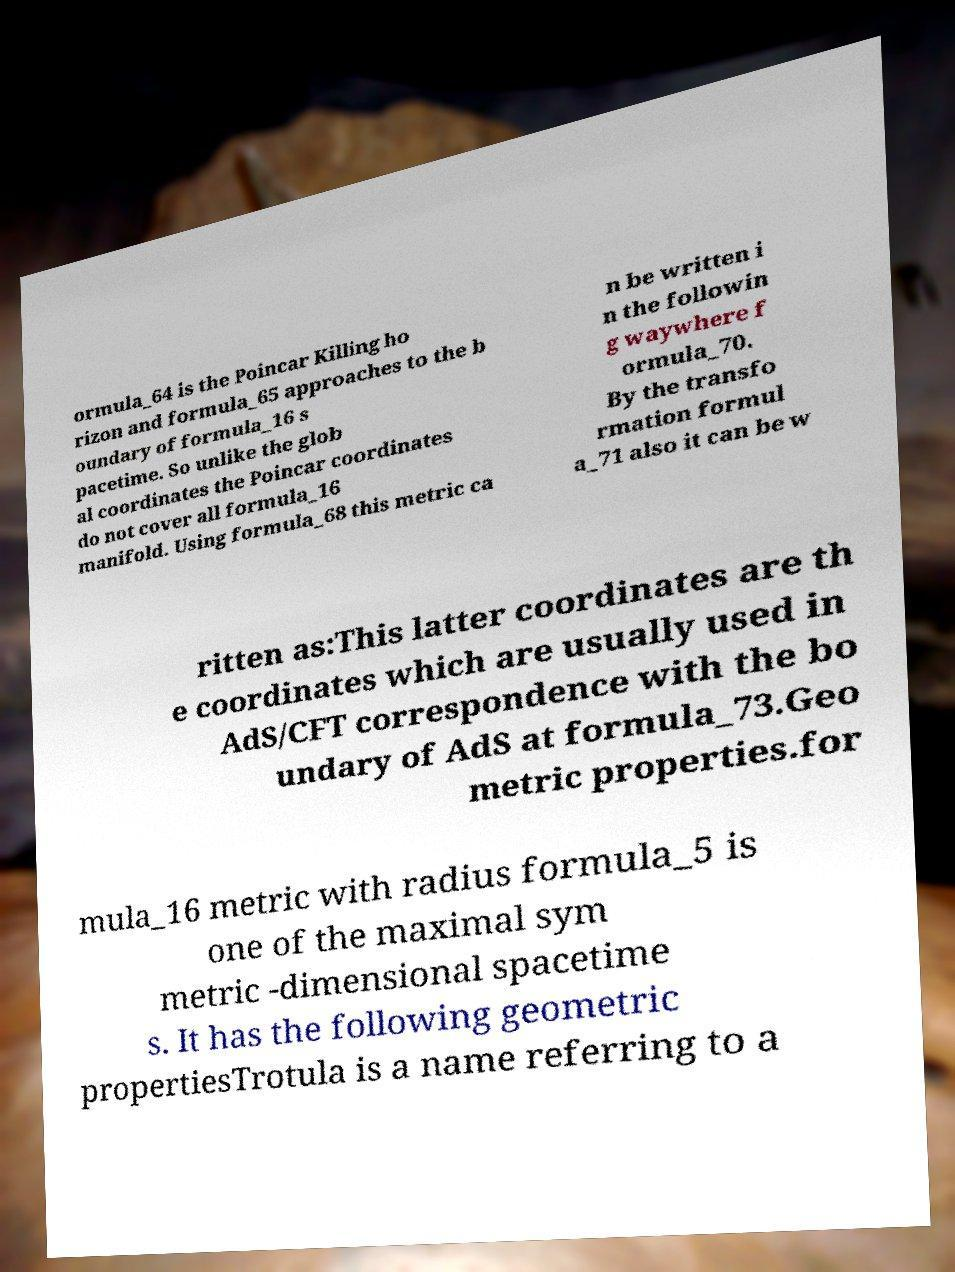For documentation purposes, I need the text within this image transcribed. Could you provide that? ormula_64 is the Poincar Killing ho rizon and formula_65 approaches to the b oundary of formula_16 s pacetime. So unlike the glob al coordinates the Poincar coordinates do not cover all formula_16 manifold. Using formula_68 this metric ca n be written i n the followin g waywhere f ormula_70. By the transfo rmation formul a_71 also it can be w ritten as:This latter coordinates are th e coordinates which are usually used in AdS/CFT correspondence with the bo undary of AdS at formula_73.Geo metric properties.for mula_16 metric with radius formula_5 is one of the maximal sym metric -dimensional spacetime s. It has the following geometric propertiesTrotula is a name referring to a 